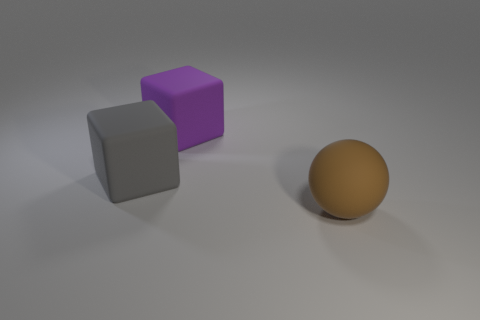Is there another small thing that has the same shape as the purple matte thing?
Your answer should be very brief. No. There is a big thing on the left side of the large purple cube; does it have the same shape as the large purple matte object?
Your answer should be very brief. Yes. How many rubber objects are behind the big gray block and on the right side of the big purple object?
Your response must be concise. 0. What shape is the large thing behind the large gray block?
Your answer should be very brief. Cube. What number of things have the same material as the brown sphere?
Provide a short and direct response. 2. There is a gray rubber thing; is its shape the same as the object that is in front of the large gray matte object?
Your answer should be very brief. No. There is a big block on the right side of the gray cube that is in front of the big purple block; is there a big cube that is on the right side of it?
Give a very brief answer. No. What size is the rubber thing that is right of the purple matte thing?
Ensure brevity in your answer.  Large. There is a brown sphere that is the same size as the gray block; what material is it?
Your answer should be very brief. Rubber. Is the big brown rubber thing the same shape as the big purple thing?
Offer a very short reply. No. 